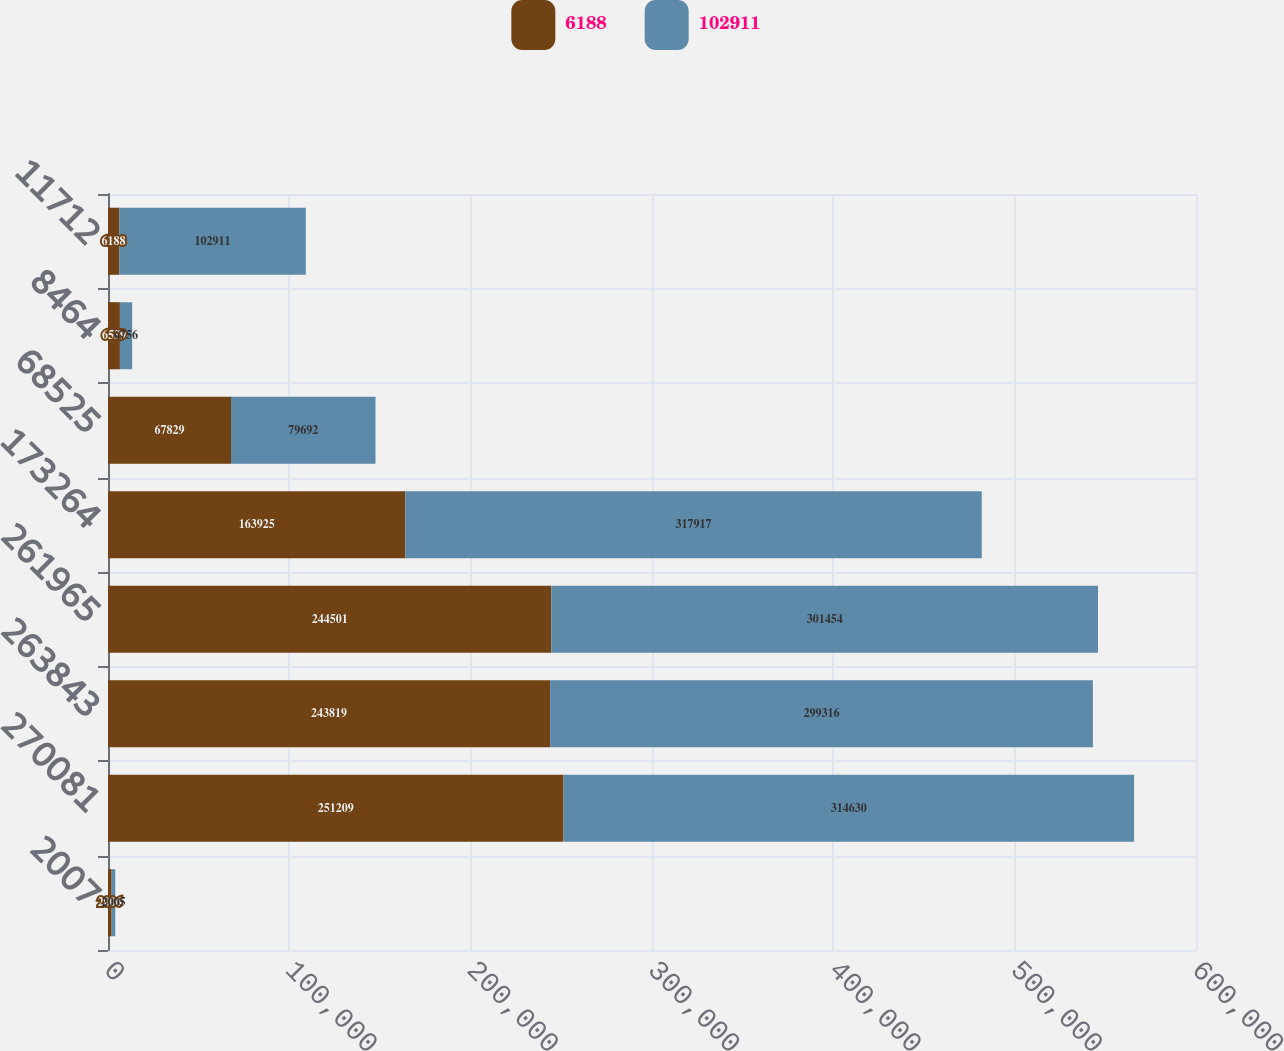Convert chart to OTSL. <chart><loc_0><loc_0><loc_500><loc_500><stacked_bar_chart><ecel><fcel>2007<fcel>270081<fcel>263843<fcel>261965<fcel>173264<fcel>68525<fcel>8464<fcel>11712<nl><fcel>6188<fcel>2006<fcel>251209<fcel>243819<fcel>244501<fcel>163925<fcel>67829<fcel>6559<fcel>6188<nl><fcel>102911<fcel>2005<fcel>314630<fcel>299316<fcel>301454<fcel>317917<fcel>79692<fcel>6756<fcel>102911<nl></chart> 